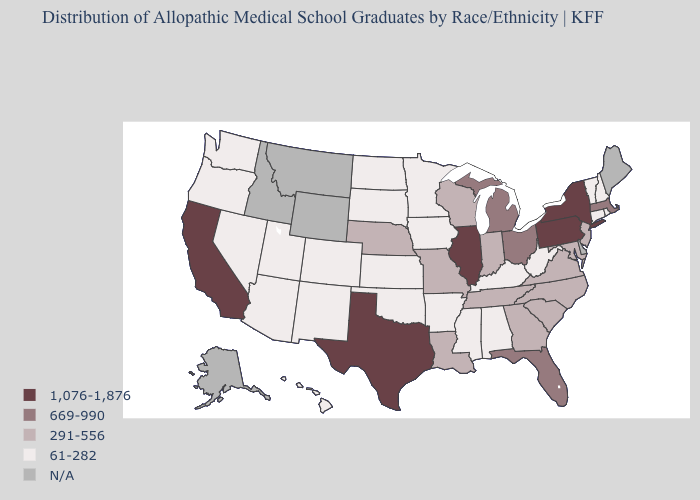Which states have the lowest value in the West?
Answer briefly. Arizona, Colorado, Hawaii, Nevada, New Mexico, Oregon, Utah, Washington. What is the highest value in the West ?
Write a very short answer. 1,076-1,876. Which states have the lowest value in the USA?
Keep it brief. Alabama, Arizona, Arkansas, Colorado, Connecticut, Hawaii, Iowa, Kansas, Kentucky, Minnesota, Mississippi, Nevada, New Hampshire, New Mexico, North Dakota, Oklahoma, Oregon, Rhode Island, South Dakota, Utah, Vermont, Washington, West Virginia. Which states have the lowest value in the USA?
Give a very brief answer. Alabama, Arizona, Arkansas, Colorado, Connecticut, Hawaii, Iowa, Kansas, Kentucky, Minnesota, Mississippi, Nevada, New Hampshire, New Mexico, North Dakota, Oklahoma, Oregon, Rhode Island, South Dakota, Utah, Vermont, Washington, West Virginia. Which states have the lowest value in the West?
Short answer required. Arizona, Colorado, Hawaii, Nevada, New Mexico, Oregon, Utah, Washington. Does Kentucky have the lowest value in the USA?
Be succinct. Yes. Name the states that have a value in the range 669-990?
Give a very brief answer. Florida, Massachusetts, Michigan, Ohio. Does the first symbol in the legend represent the smallest category?
Answer briefly. No. Which states hav the highest value in the Northeast?
Concise answer only. New York, Pennsylvania. Which states have the lowest value in the USA?
Keep it brief. Alabama, Arizona, Arkansas, Colorado, Connecticut, Hawaii, Iowa, Kansas, Kentucky, Minnesota, Mississippi, Nevada, New Hampshire, New Mexico, North Dakota, Oklahoma, Oregon, Rhode Island, South Dakota, Utah, Vermont, Washington, West Virginia. Name the states that have a value in the range 669-990?
Write a very short answer. Florida, Massachusetts, Michigan, Ohio. Among the states that border Delaware , which have the lowest value?
Write a very short answer. Maryland, New Jersey. Among the states that border Missouri , does Illinois have the lowest value?
Give a very brief answer. No. Among the states that border Indiana , which have the lowest value?
Keep it brief. Kentucky. 